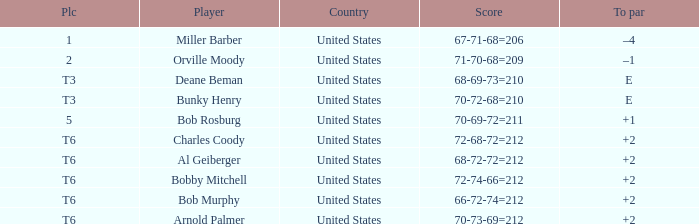Who is the player with a t6 place and a 72-68-72=212 score? Charles Coody. 